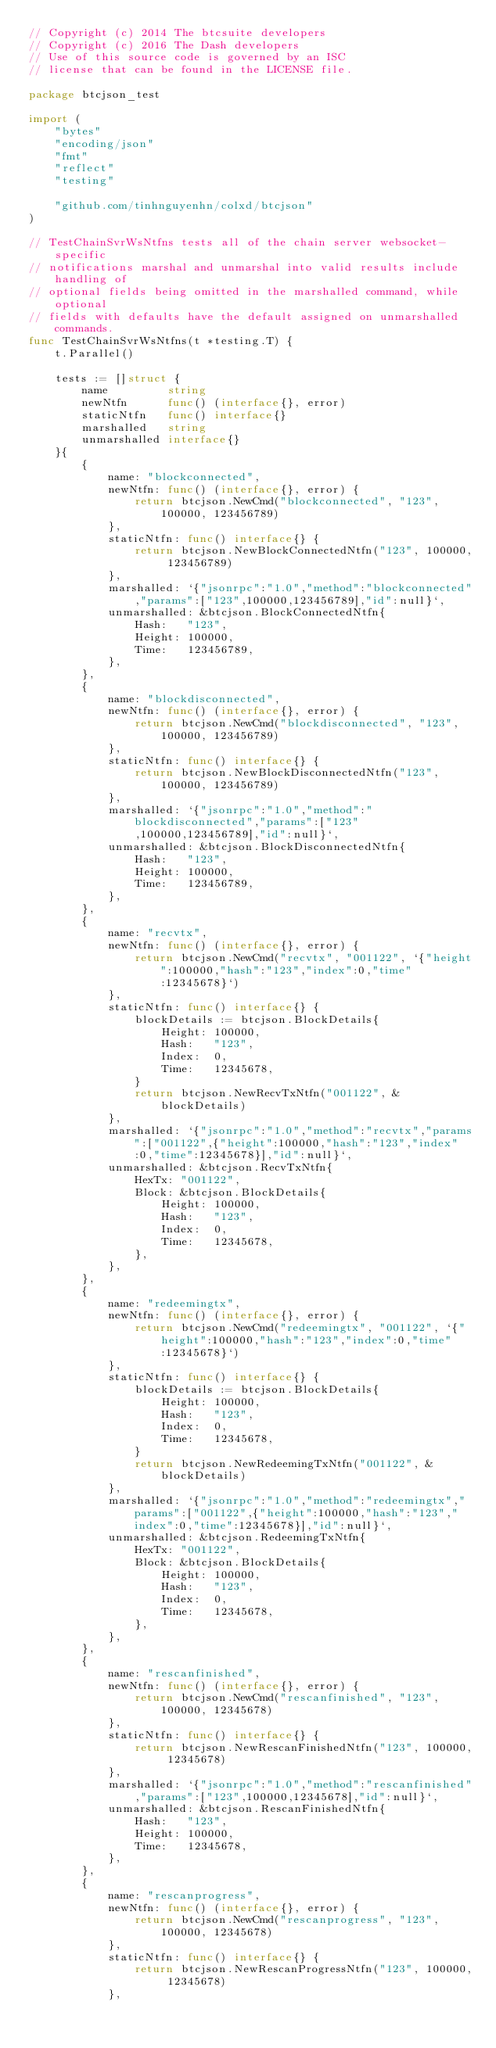Convert code to text. <code><loc_0><loc_0><loc_500><loc_500><_Go_>// Copyright (c) 2014 The btcsuite developers
// Copyright (c) 2016 The Dash developers
// Use of this source code is governed by an ISC
// license that can be found in the LICENSE file.

package btcjson_test

import (
	"bytes"
	"encoding/json"
	"fmt"
	"reflect"
	"testing"

	"github.com/tinhnguyenhn/colxd/btcjson"
)

// TestChainSvrWsNtfns tests all of the chain server websocket-specific
// notifications marshal and unmarshal into valid results include handling of
// optional fields being omitted in the marshalled command, while optional
// fields with defaults have the default assigned on unmarshalled commands.
func TestChainSvrWsNtfns(t *testing.T) {
	t.Parallel()

	tests := []struct {
		name         string
		newNtfn      func() (interface{}, error)
		staticNtfn   func() interface{}
		marshalled   string
		unmarshalled interface{}
	}{
		{
			name: "blockconnected",
			newNtfn: func() (interface{}, error) {
				return btcjson.NewCmd("blockconnected", "123", 100000, 123456789)
			},
			staticNtfn: func() interface{} {
				return btcjson.NewBlockConnectedNtfn("123", 100000, 123456789)
			},
			marshalled: `{"jsonrpc":"1.0","method":"blockconnected","params":["123",100000,123456789],"id":null}`,
			unmarshalled: &btcjson.BlockConnectedNtfn{
				Hash:   "123",
				Height: 100000,
				Time:   123456789,
			},
		},
		{
			name: "blockdisconnected",
			newNtfn: func() (interface{}, error) {
				return btcjson.NewCmd("blockdisconnected", "123", 100000, 123456789)
			},
			staticNtfn: func() interface{} {
				return btcjson.NewBlockDisconnectedNtfn("123", 100000, 123456789)
			},
			marshalled: `{"jsonrpc":"1.0","method":"blockdisconnected","params":["123",100000,123456789],"id":null}`,
			unmarshalled: &btcjson.BlockDisconnectedNtfn{
				Hash:   "123",
				Height: 100000,
				Time:   123456789,
			},
		},
		{
			name: "recvtx",
			newNtfn: func() (interface{}, error) {
				return btcjson.NewCmd("recvtx", "001122", `{"height":100000,"hash":"123","index":0,"time":12345678}`)
			},
			staticNtfn: func() interface{} {
				blockDetails := btcjson.BlockDetails{
					Height: 100000,
					Hash:   "123",
					Index:  0,
					Time:   12345678,
				}
				return btcjson.NewRecvTxNtfn("001122", &blockDetails)
			},
			marshalled: `{"jsonrpc":"1.0","method":"recvtx","params":["001122",{"height":100000,"hash":"123","index":0,"time":12345678}],"id":null}`,
			unmarshalled: &btcjson.RecvTxNtfn{
				HexTx: "001122",
				Block: &btcjson.BlockDetails{
					Height: 100000,
					Hash:   "123",
					Index:  0,
					Time:   12345678,
				},
			},
		},
		{
			name: "redeemingtx",
			newNtfn: func() (interface{}, error) {
				return btcjson.NewCmd("redeemingtx", "001122", `{"height":100000,"hash":"123","index":0,"time":12345678}`)
			},
			staticNtfn: func() interface{} {
				blockDetails := btcjson.BlockDetails{
					Height: 100000,
					Hash:   "123",
					Index:  0,
					Time:   12345678,
				}
				return btcjson.NewRedeemingTxNtfn("001122", &blockDetails)
			},
			marshalled: `{"jsonrpc":"1.0","method":"redeemingtx","params":["001122",{"height":100000,"hash":"123","index":0,"time":12345678}],"id":null}`,
			unmarshalled: &btcjson.RedeemingTxNtfn{
				HexTx: "001122",
				Block: &btcjson.BlockDetails{
					Height: 100000,
					Hash:   "123",
					Index:  0,
					Time:   12345678,
				},
			},
		},
		{
			name: "rescanfinished",
			newNtfn: func() (interface{}, error) {
				return btcjson.NewCmd("rescanfinished", "123", 100000, 12345678)
			},
			staticNtfn: func() interface{} {
				return btcjson.NewRescanFinishedNtfn("123", 100000, 12345678)
			},
			marshalled: `{"jsonrpc":"1.0","method":"rescanfinished","params":["123",100000,12345678],"id":null}`,
			unmarshalled: &btcjson.RescanFinishedNtfn{
				Hash:   "123",
				Height: 100000,
				Time:   12345678,
			},
		},
		{
			name: "rescanprogress",
			newNtfn: func() (interface{}, error) {
				return btcjson.NewCmd("rescanprogress", "123", 100000, 12345678)
			},
			staticNtfn: func() interface{} {
				return btcjson.NewRescanProgressNtfn("123", 100000, 12345678)
			},</code> 